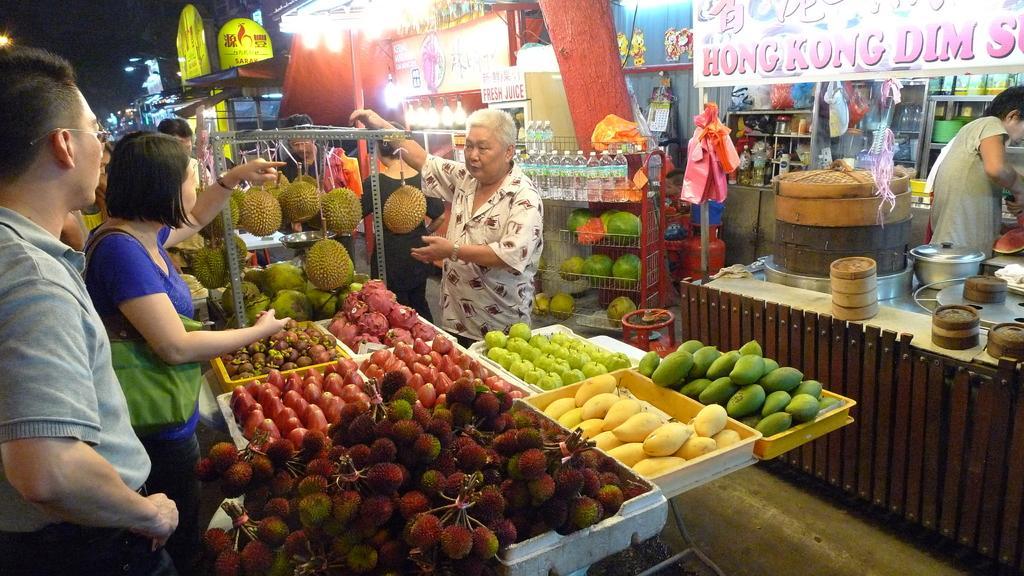In one or two sentences, can you explain what this image depicts? This is an outside view. on the left side, I can see many trays which are filled with the fruits. There are many fruits like Jackfruit, coconuts, apple, guavas, mangoes and some other fruits. There are few people standing around the table and speaking to each other. On the right side, I can see some food courts. There is a table on which I can see many bowls and a person is standing. At the back of him I can see many boxes, bottles and bowls are arranged in the racks and also I can see few boards. 